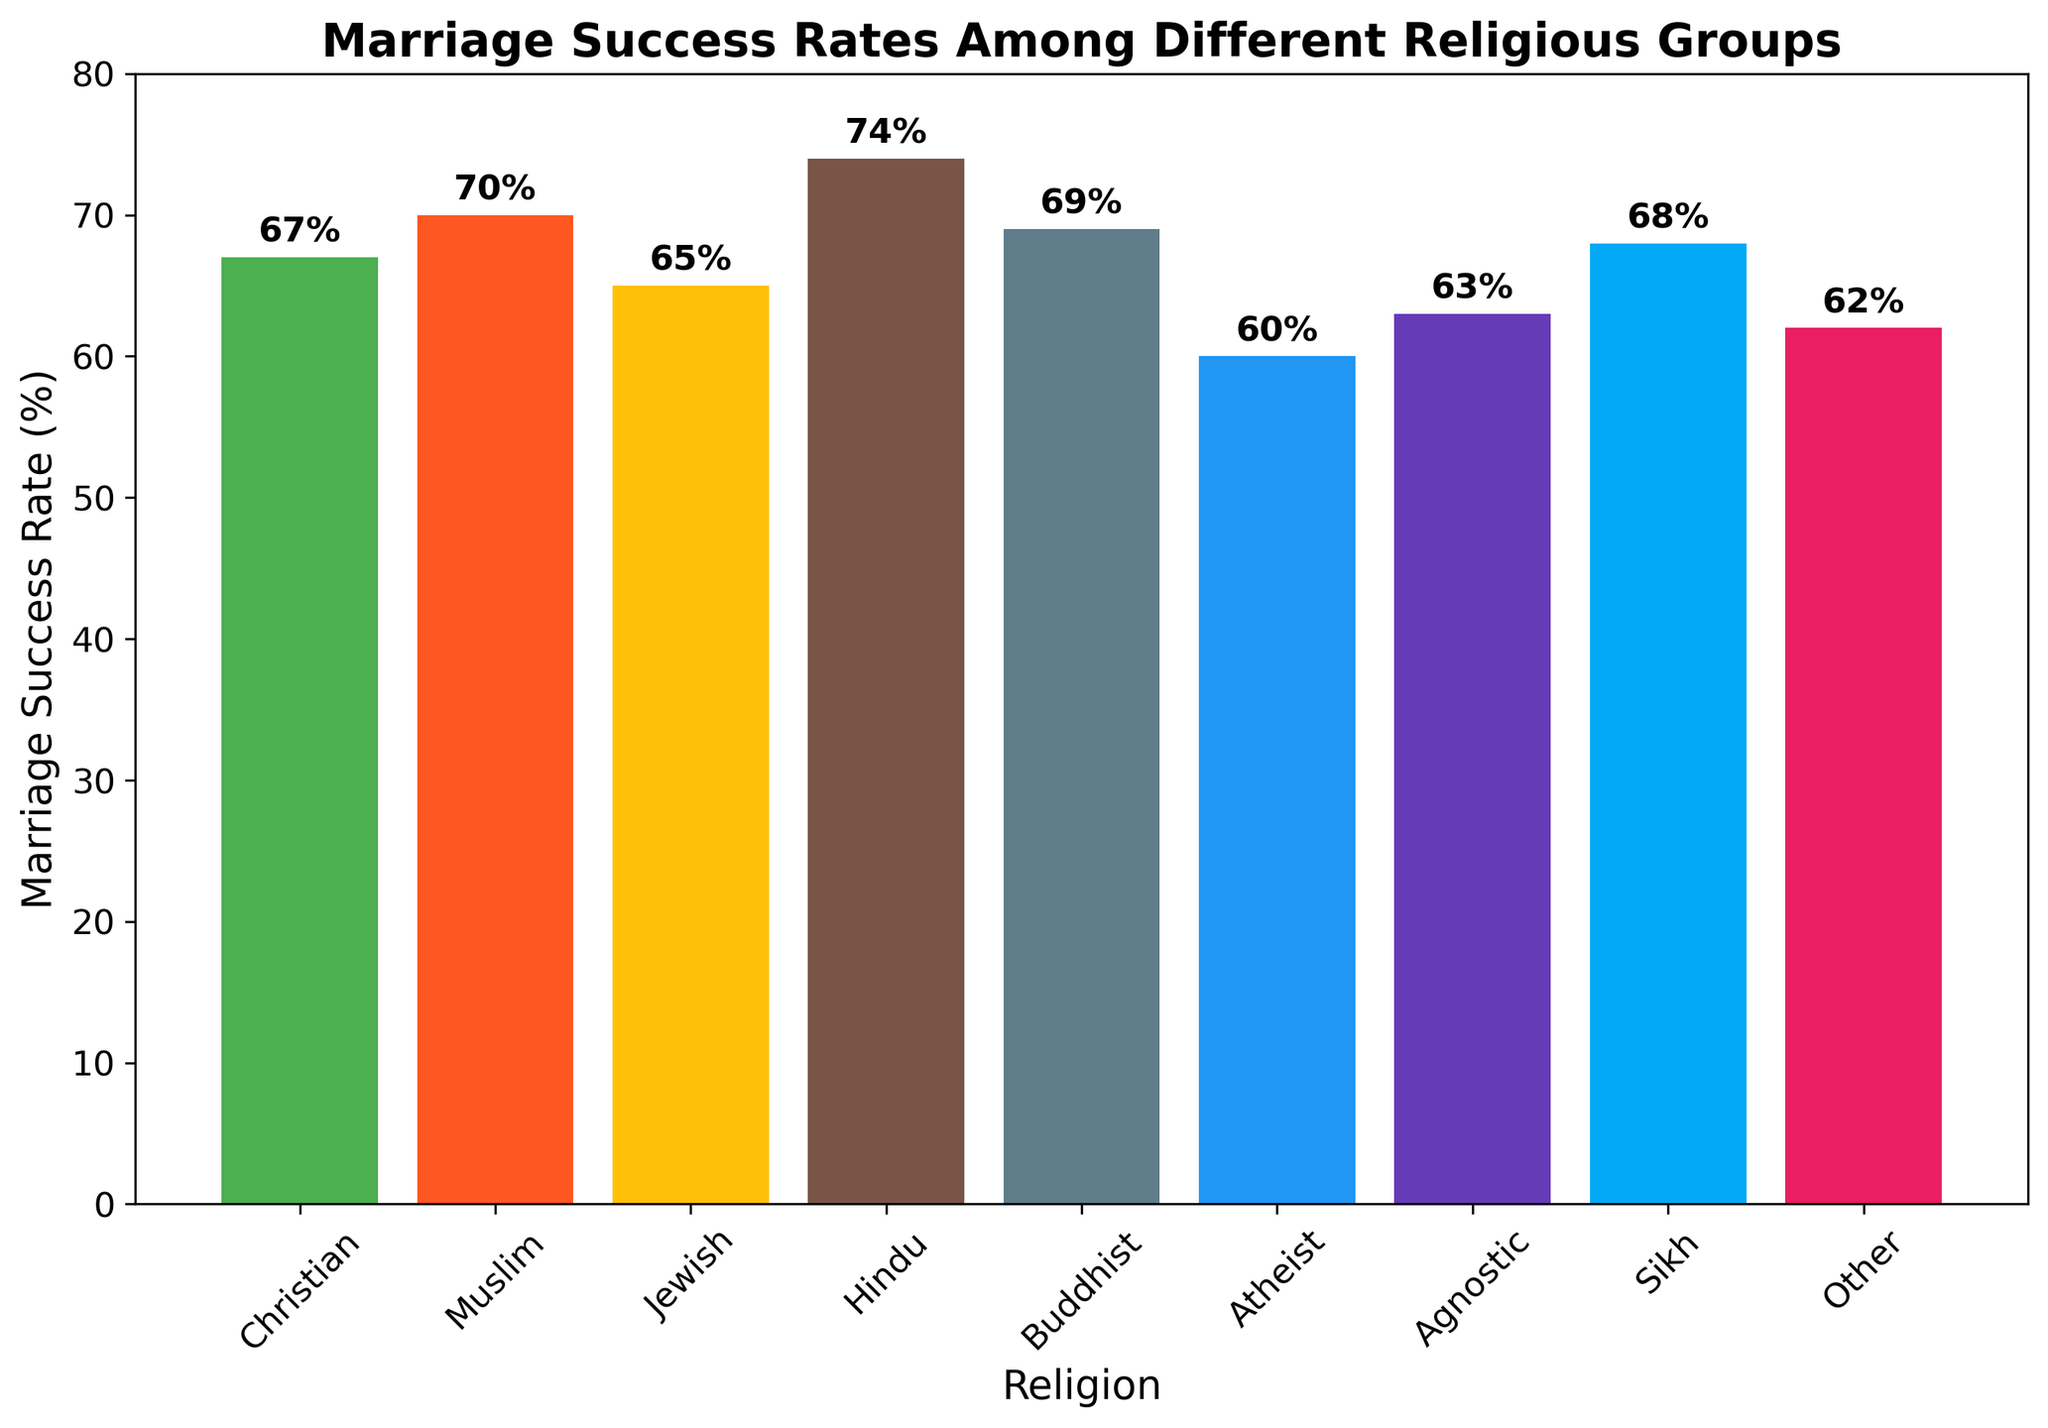What is the highest marriage success rate among the religious groups? By visually inspecting the heights of the bars, we can identify that the highest bar corresponds to the "Hindu" group with a marriage success rate of 74%.
Answer: 74% Which religious group has a lower marriage success rate: Christian or Buddhist? By comparing the heights of the bars for "Christian" and "Buddhist", we see that the bar for "Christian" is shorter (67%) than the bar for "Buddhist" (69%). Thus, "Christian" has a lower marriage success rate.
Answer: Christian What is the approximate difference in marriage success rate between the group with the highest rate and the group with the lowest rate? The group with the highest rate is "Hindu" (74%), and the group with the lowest rate is "Atheist" (60%). The difference is calculated as 74% - 60% = 14%.
Answer: 14% Which two religious groups have marriage success rates closest to each other, and what is the difference? By visually comparing the heights of the bars, "Christian" (67%) and "Sikh" (68%) are closest with a difference of 68% - 67% = 1%.
Answer: Christian and Sikh, 1% Rank the religious groups from highest to lowest marriage success rates. By ordering the heights of the bars from tallest to shortest, we get: Hindu (74%), Muslim (70%), Buddhist (69%), Sikh (68%), Christian (67%), Jewish (65%), Agnostic (63%), Other (62%), Atheist (60%).
Answer: Hindu, Muslim, Buddhist, Sikh, Christian, Jewish, Agnostic, Other, Atheist What is the combined marriage success rate of Muslim and Buddhist groups? The marriage success rate of the "Muslim" group is 70%, and the rate for the "Buddhist" group is 69%. Their combined rate is 70% + 69% = 139%.
Answer: 139% Which religious group stands at the middle position in terms of marriage success rate, and what is the rate? By ranking all groups from highest to lowest and finding the middle one, the middle position is held by the "Christian" group with a marriage success rate of 67%.
Answer: Christian, 67% What is the average marriage success rate of all religious groups? Sum the marriage success rates of all groups and divide by the number of groups: (67 + 70 + 65 + 74 + 69 + 60 + 63 + 68 + 62) / 9 = 598 / 9 ≈ 66.44%.
Answer: 66.44% What color represents the bar for the Sikh group and what is their marriage success rate? The bar for the "Sikh" group is represented by a specific color, which can be identified as blueish. The marriage success rate for this group is 68%.
Answer: Blueish, 68% What is the total percentage of marriage success rates for all groups excluding Atheist and Agnostic? Excluding the "Atheist" (60%) and "Agnostic" (63%) groups, the remaining percentages are summed as follows: 67 + 70 + 65 + 74 + 69 + 68 + 62 = 475%.
Answer: 475% 